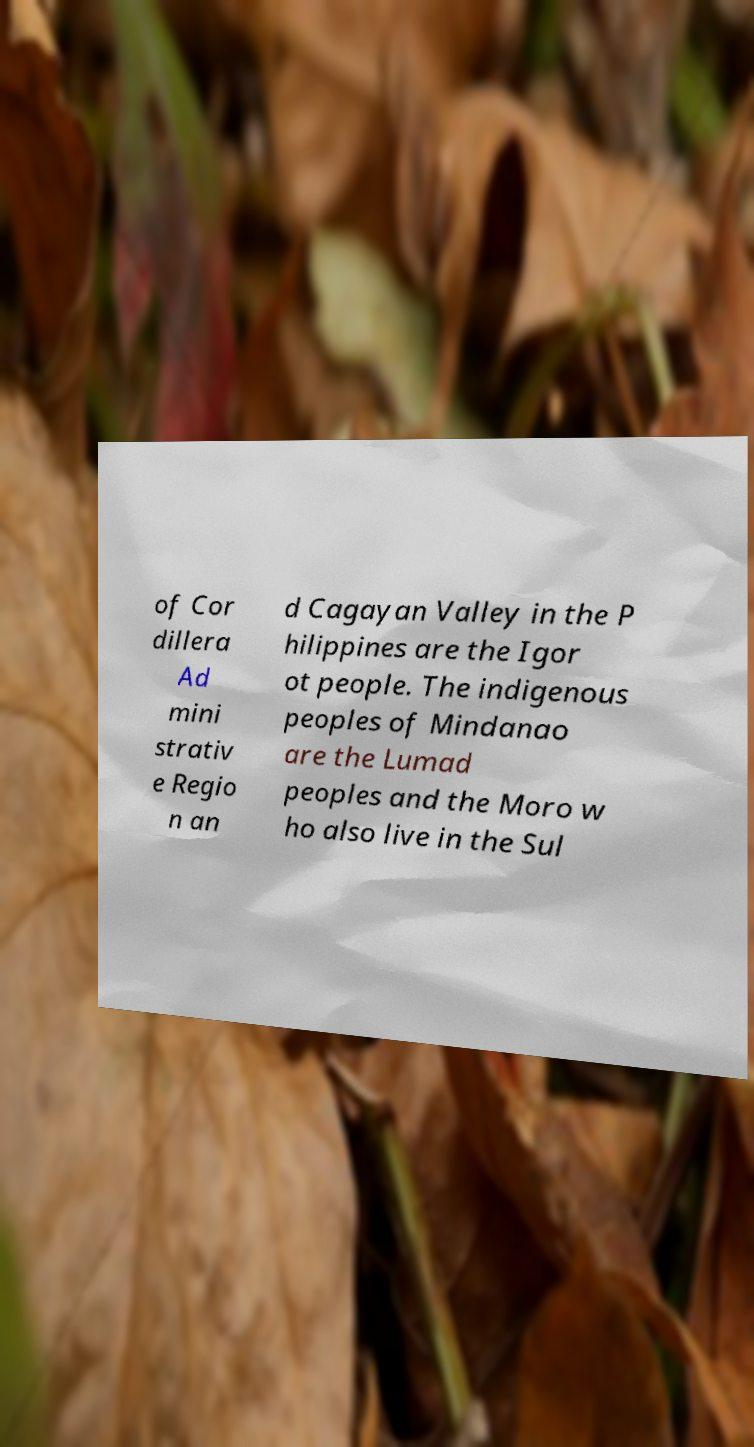Could you assist in decoding the text presented in this image and type it out clearly? of Cor dillera Ad mini strativ e Regio n an d Cagayan Valley in the P hilippines are the Igor ot people. The indigenous peoples of Mindanao are the Lumad peoples and the Moro w ho also live in the Sul 